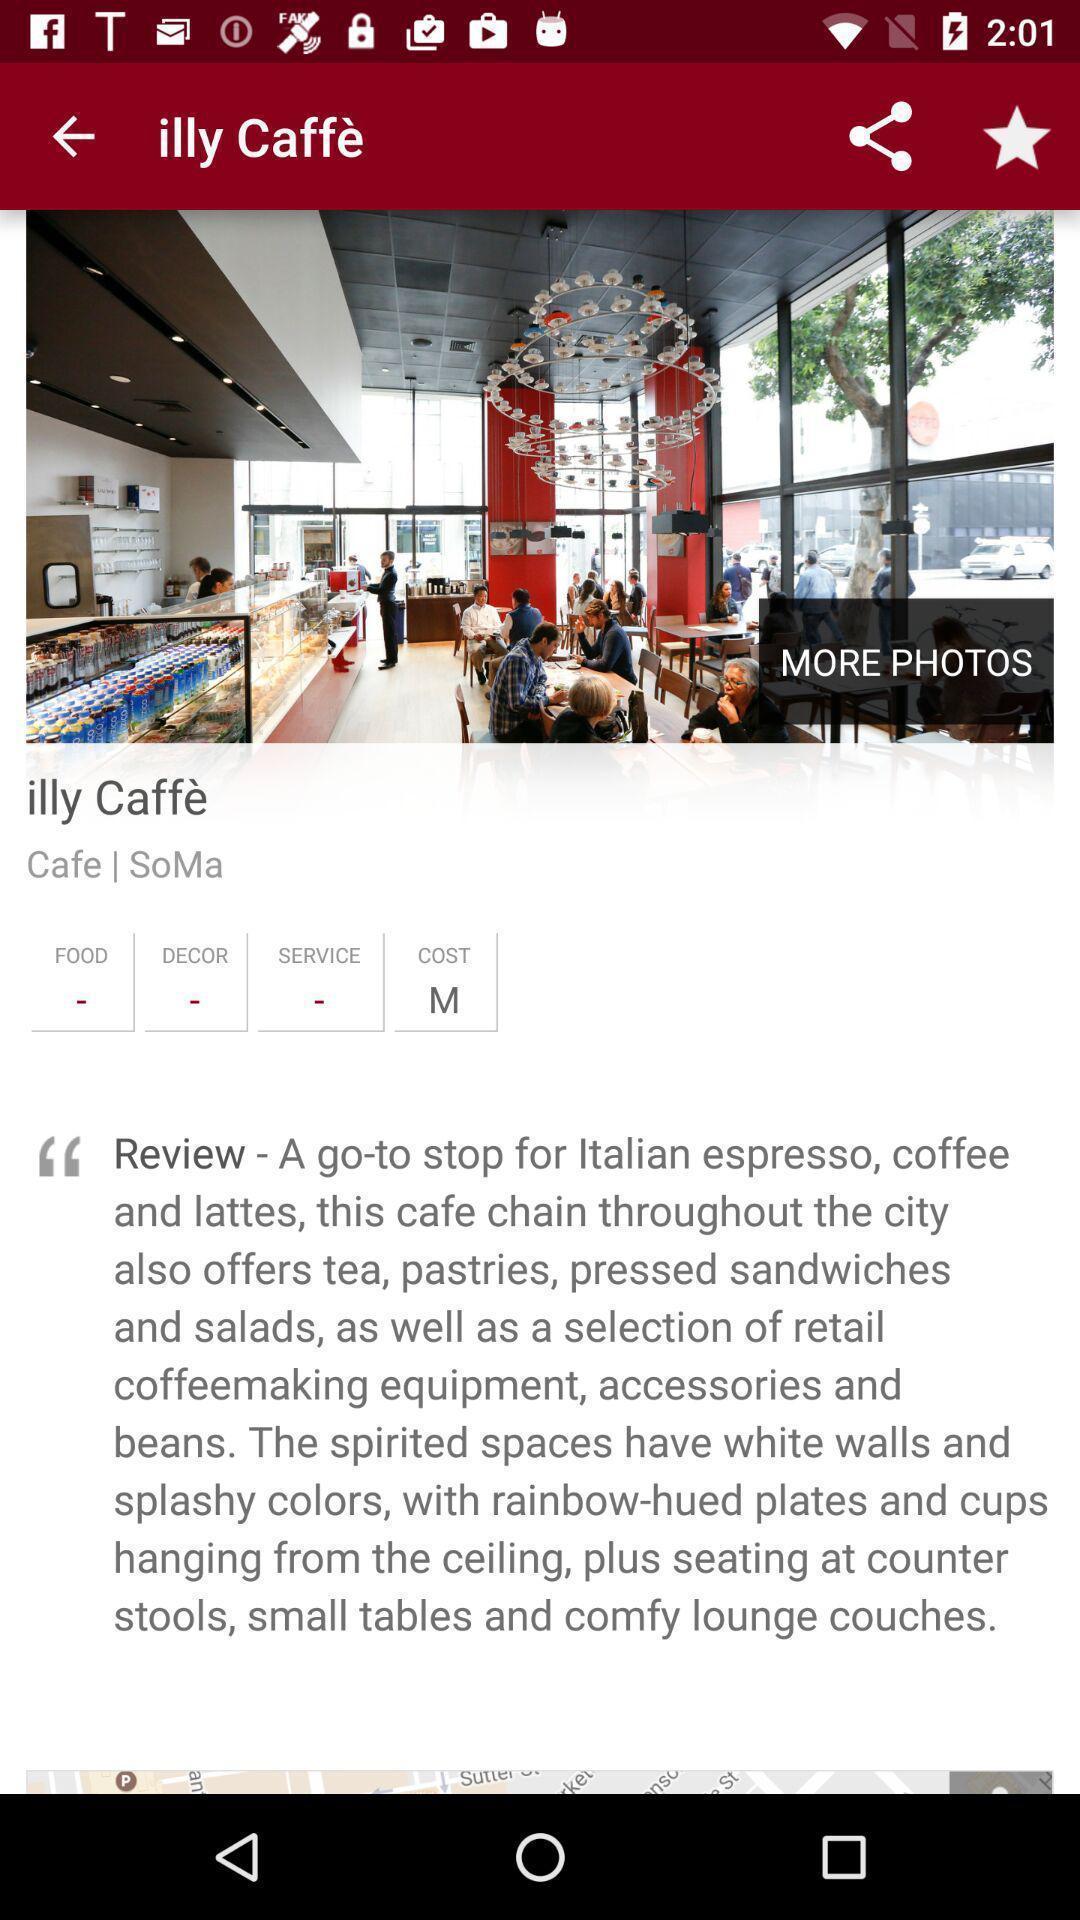Please provide a description for this image. Page displaying information of a coffee company. 